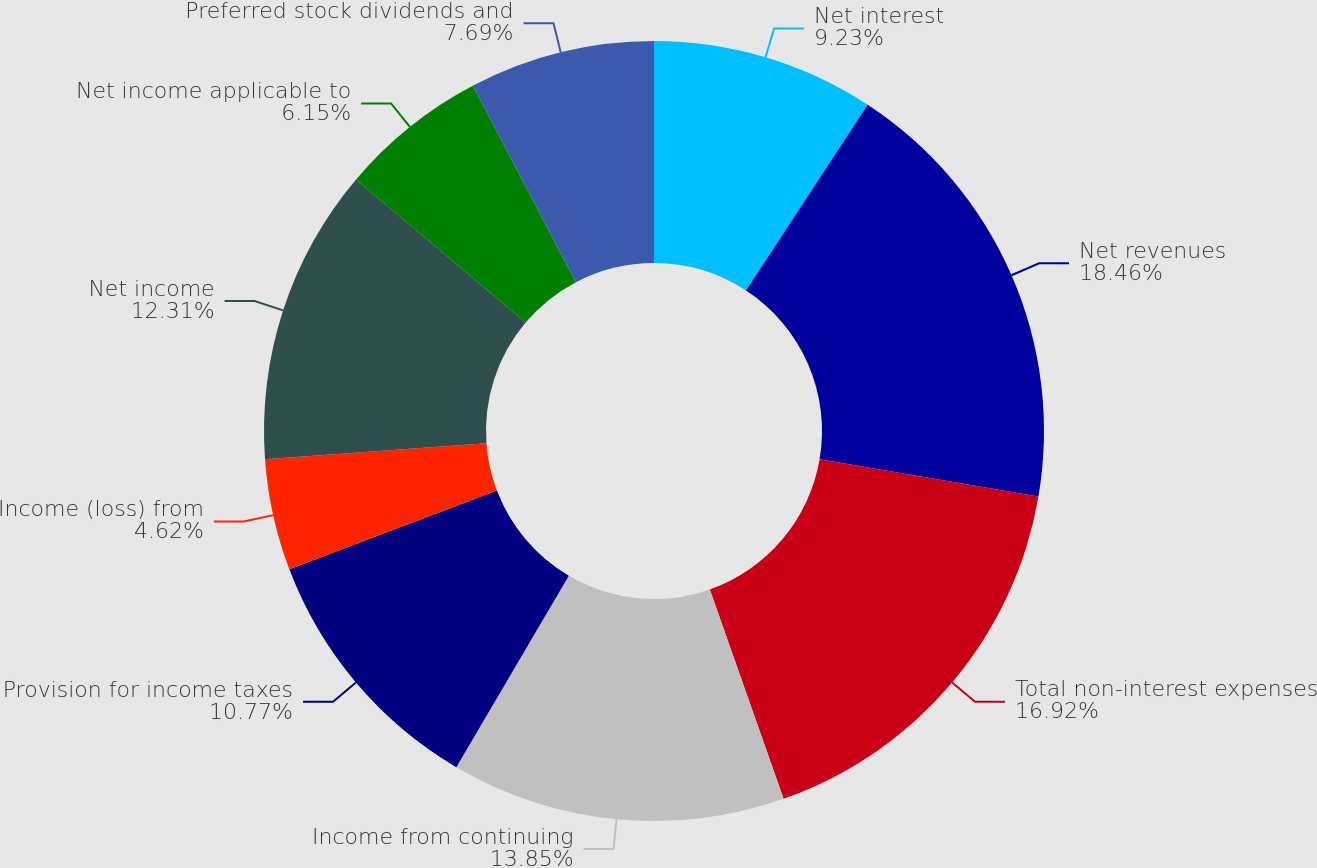<chart> <loc_0><loc_0><loc_500><loc_500><pie_chart><fcel>Net interest<fcel>Net revenues<fcel>Total non-interest expenses<fcel>Income from continuing<fcel>Provision for income taxes<fcel>Income (loss) from<fcel>Net income<fcel>Net income applicable to<fcel>Preferred stock dividends and<nl><fcel>9.23%<fcel>18.46%<fcel>16.92%<fcel>13.85%<fcel>10.77%<fcel>4.62%<fcel>12.31%<fcel>6.15%<fcel>7.69%<nl></chart> 